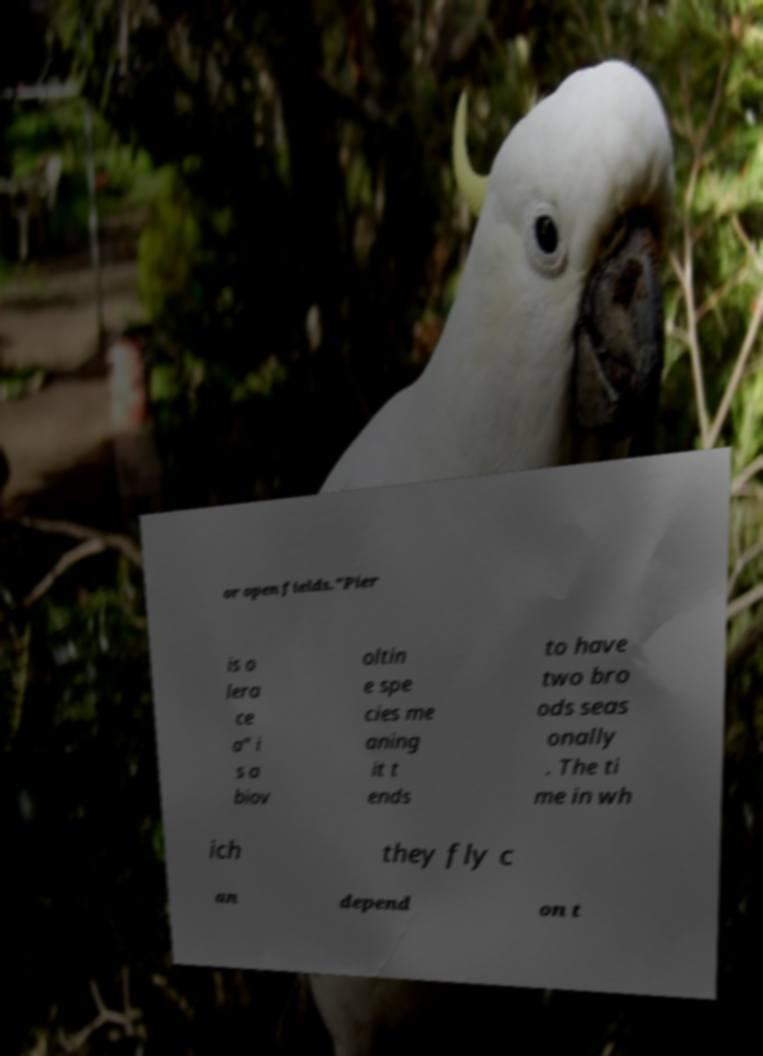Can you read and provide the text displayed in the image?This photo seems to have some interesting text. Can you extract and type it out for me? or open fields."Pier is o lera ce a" i s a biov oltin e spe cies me aning it t ends to have two bro ods seas onally . The ti me in wh ich they fly c an depend on t 